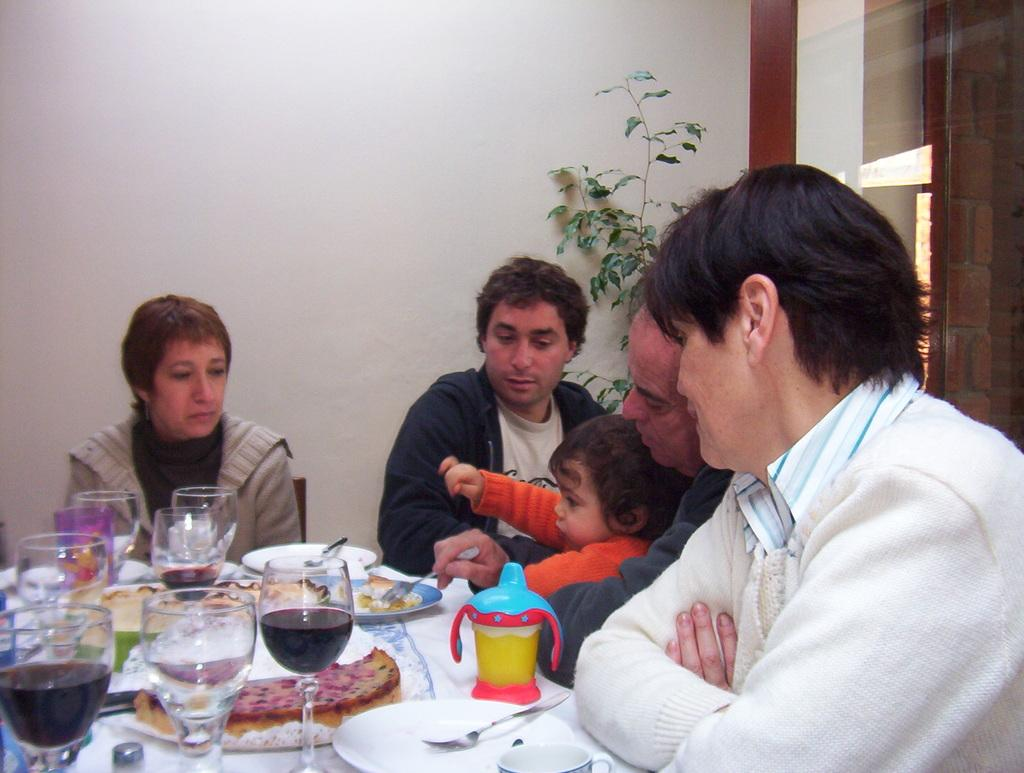How many people are in the image? There is a group of people in the image, but the exact number is not specified. What are the people wearing? The people in the image are wearing clothes. Where are the people sitting in relation to the table? The people are sitting in front of a table. What items can be found on the table? The table contains glasses and plates. What is located in front of the wall? There is a plant in front of a wall. What type of print can be seen on the people's clothes in the image? The provided facts do not mention any specific prints on the people's clothes, so we cannot determine that information from the image. 